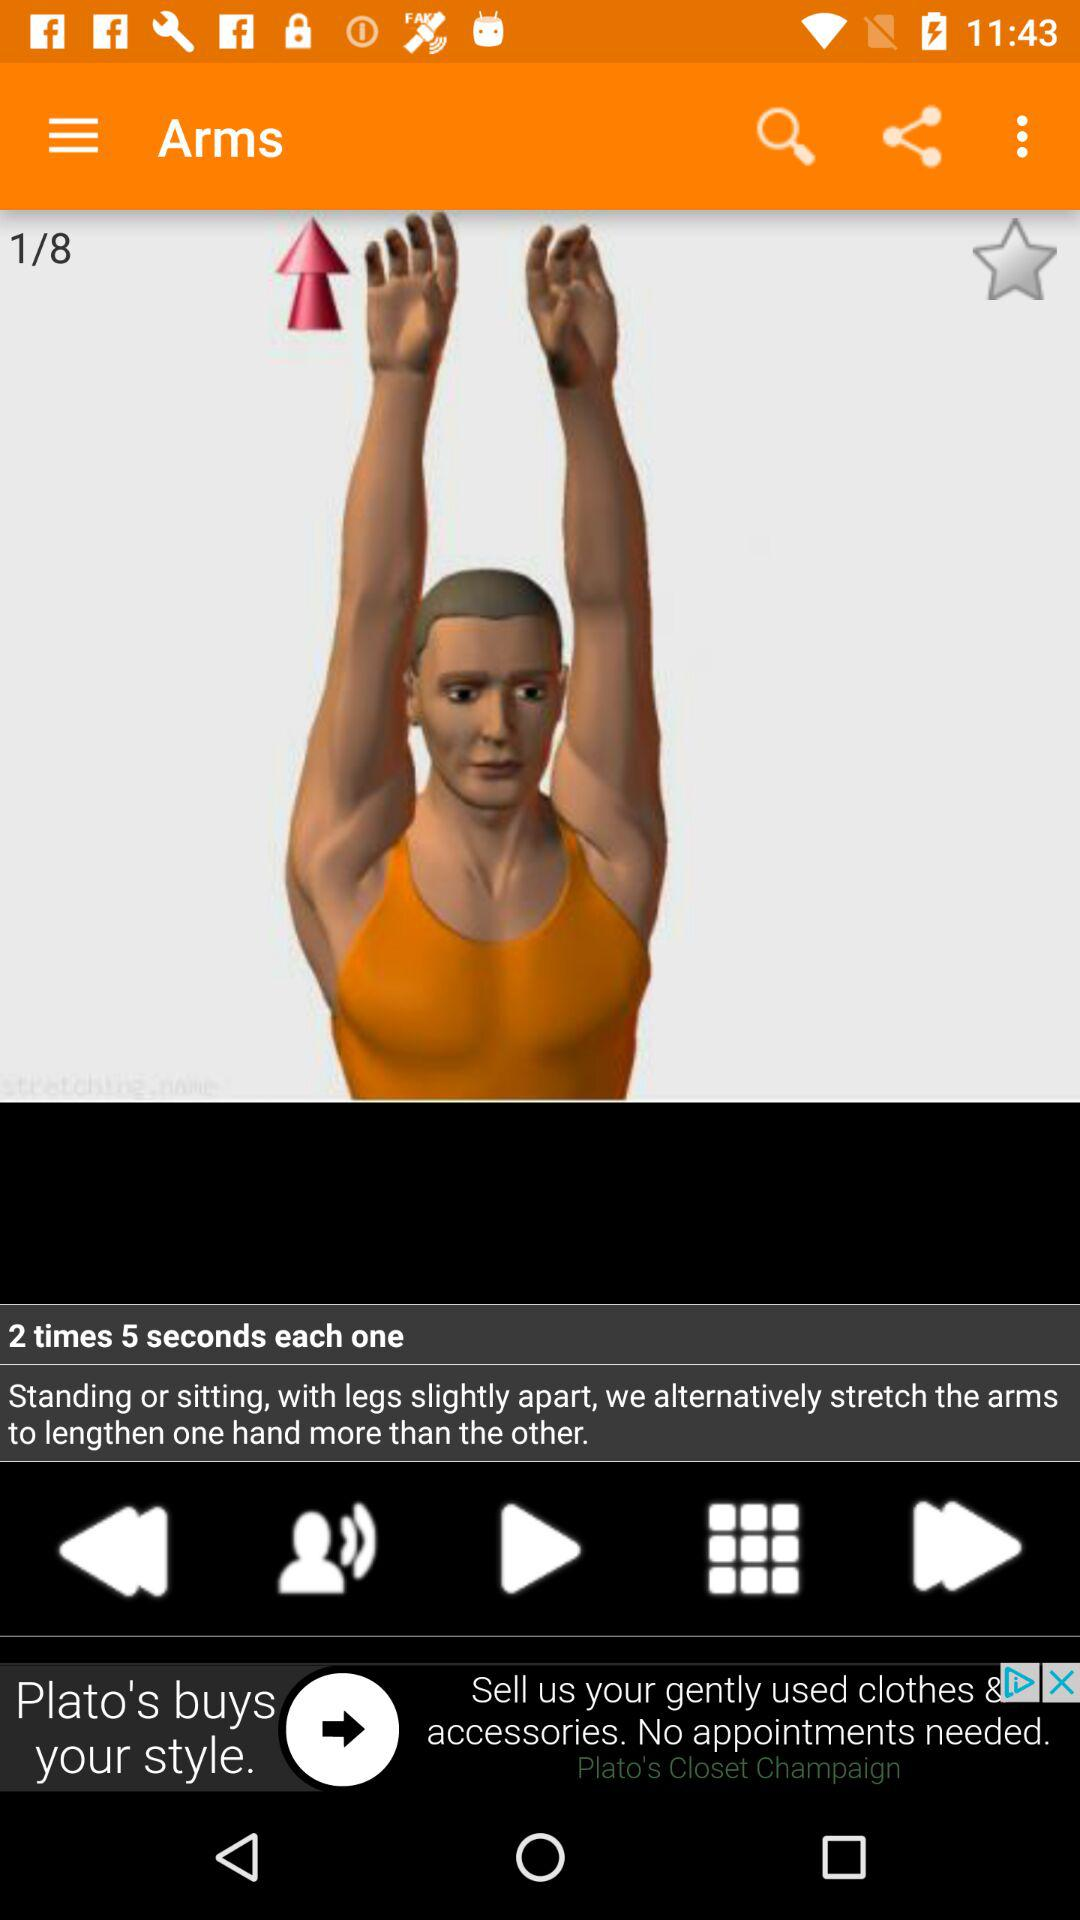What is the duration of each repetition? The duration of each repetition is 5 seconds. 